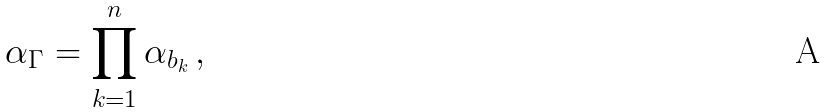Convert formula to latex. <formula><loc_0><loc_0><loc_500><loc_500>\alpha _ { \Gamma } = \prod _ { k = 1 } ^ { n } \alpha _ { b _ { k } } \, ,</formula> 